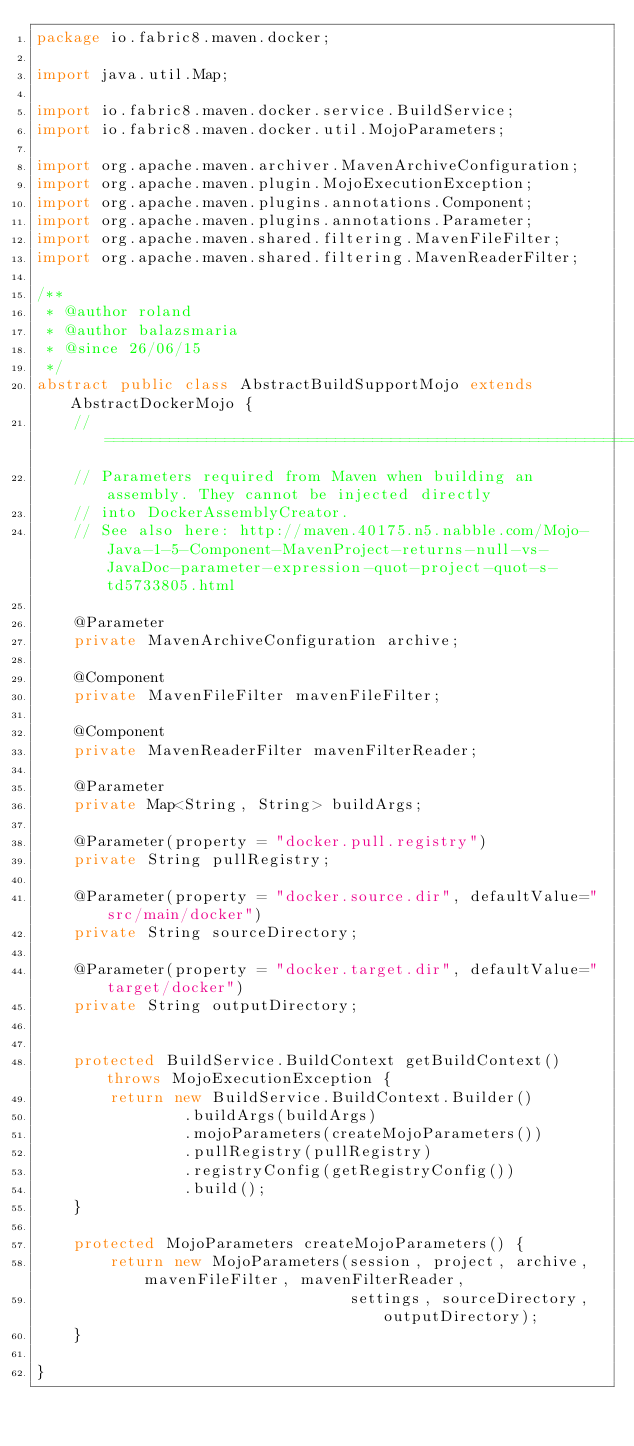<code> <loc_0><loc_0><loc_500><loc_500><_Java_>package io.fabric8.maven.docker;

import java.util.Map;

import io.fabric8.maven.docker.service.BuildService;
import io.fabric8.maven.docker.util.MojoParameters;

import org.apache.maven.archiver.MavenArchiveConfiguration;
import org.apache.maven.plugin.MojoExecutionException;
import org.apache.maven.plugins.annotations.Component;
import org.apache.maven.plugins.annotations.Parameter;
import org.apache.maven.shared.filtering.MavenFileFilter;
import org.apache.maven.shared.filtering.MavenReaderFilter;

/**
 * @author roland
 * @author balazsmaria
 * @since 26/06/15
 */
abstract public class AbstractBuildSupportMojo extends AbstractDockerMojo {
    // ==============================================================================================================
    // Parameters required from Maven when building an assembly. They cannot be injected directly
    // into DockerAssemblyCreator.
    // See also here: http://maven.40175.n5.nabble.com/Mojo-Java-1-5-Component-MavenProject-returns-null-vs-JavaDoc-parameter-expression-quot-project-quot-s-td5733805.html

    @Parameter
    private MavenArchiveConfiguration archive;

    @Component
    private MavenFileFilter mavenFileFilter;

    @Component
    private MavenReaderFilter mavenFilterReader;

    @Parameter
    private Map<String, String> buildArgs;

    @Parameter(property = "docker.pull.registry")
    private String pullRegistry;

    @Parameter(property = "docker.source.dir", defaultValue="src/main/docker")
    private String sourceDirectory;

    @Parameter(property = "docker.target.dir", defaultValue="target/docker")
    private String outputDirectory;


    protected BuildService.BuildContext getBuildContext() throws MojoExecutionException {
        return new BuildService.BuildContext.Builder()
                .buildArgs(buildArgs)
                .mojoParameters(createMojoParameters())
                .pullRegistry(pullRegistry)
                .registryConfig(getRegistryConfig())
                .build();
    }

    protected MojoParameters createMojoParameters() {
        return new MojoParameters(session, project, archive, mavenFileFilter, mavenFilterReader,
                                  settings, sourceDirectory, outputDirectory);
    }

}
</code> 